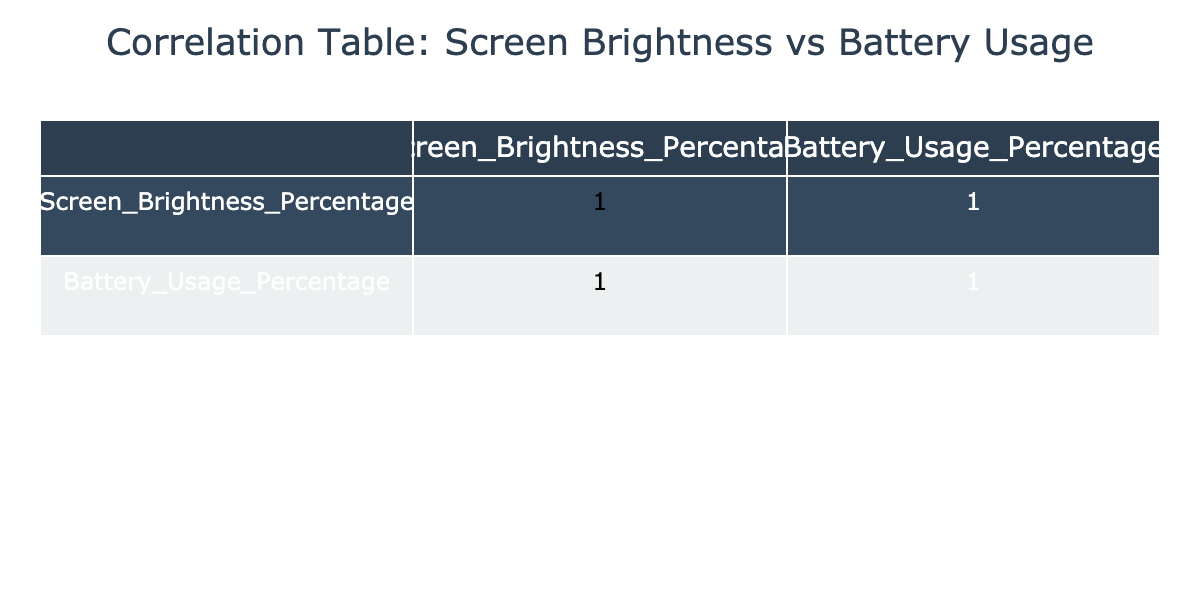What is the correlation coefficient between Screen Brightness and Battery Usage? The correlation matrix indicates that the correlation coefficient between Screen Brightness Percentage and Battery Usage Percentage is -0.98. This value suggests a strong negative correlation where increased screen brightness leads to decreased battery efficiency.
Answer: -0.98 How much battery usage is associated with a screen brightness of 60% on Windows 11? From the table, at 60% screen brightness, the Battery Usage Percentage for Windows 11 is 45.
Answer: 45 Is it true that the battery usage at a screen brightness of 100% is higher than at 50%? Yes, battery usage at 100% brightness is 85%, which is greater than 35% at 50%. This shows that as brightness increases, so does battery usage.
Answer: Yes What is the average battery usage for screen brightness levels from 40% to 100%? The battery usage percentages from 40% to 100% are 25, 35, 45, 55, 65, 75, and 85. Adding these values gives 385, and dividing by the number of values (7) results in an average of approximately 55.
Answer: 55 At which screen brightness does the battery usage drop below 25%? Referring to the table, the battery usage drops below 25% at a screen brightness of 40%, as the usage at this level is 25. Hence, at 30% screen brightness and below, the usage continues to decrease further.
Answer: 30 What is the difference in battery usage between a screen brightness of 90% and 10%? At 90% brightness, the battery usage is 75%, while at 10% brightness, it is 5%. The difference is calculated as 75 - 5, which equals 70.
Answer: 70 Is there a screen brightness value associated with minimal battery consumption on any Windows operating system in the table? Yes, at 10% screen brightness, battery consumption is at its lowest at 5%. This indicates the best battery efficiency at this brightness level.
Answer: Yes What is the trend of battery usage as screen brightness decreases from 100% to 10%? The trend shows that as screen brightness decreases, the battery usage percentage consistently decreases from 85% at 100% down to 5% at 10%, indicating an inverse relationship.
Answer: Decreases consistently 